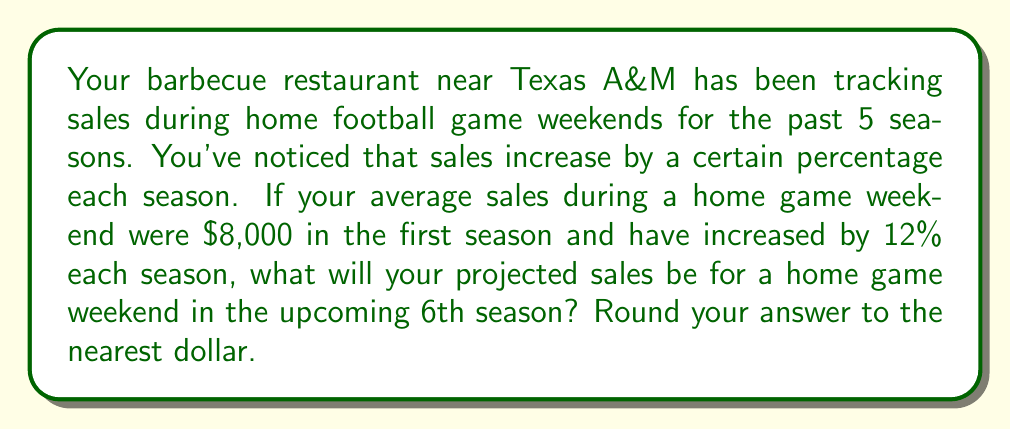Help me with this question. Let's approach this step-by-step:

1) First, we need to understand what a 12% increase means mathematically. Each season, the sales are multiplied by 1.12 (100% + 12% = 112% = 1.12).

2) We start with $8,000 in the first season and increase by 12% each season for 5 seasons. We can represent this mathematically as:

   $$8000 * (1.12)^5$$

3) Let's calculate this:
   $$8000 * (1.12)^5 = 8000 * 1.7623416$$

4) Multiplying:
   $$8000 * 1.7623416 = 14,098.7328$$

5) Rounding to the nearest dollar:
   $14,099

Therefore, based on the trend of the past 5 seasons, the projected sales for a home game weekend in the 6th season would be $14,099.
Answer: $14,099 